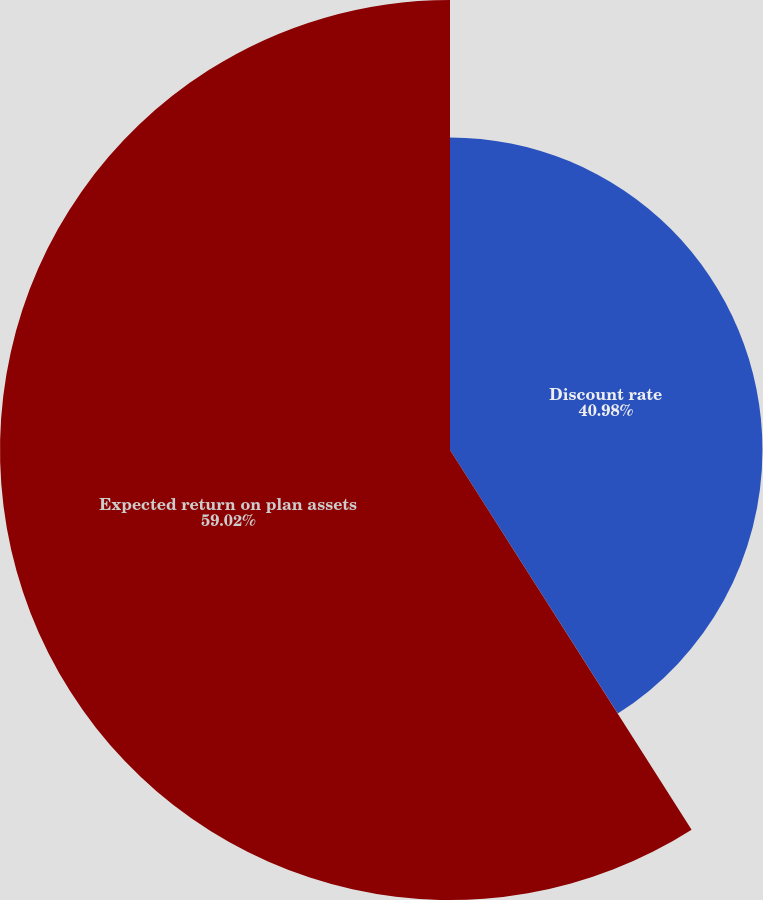Convert chart. <chart><loc_0><loc_0><loc_500><loc_500><pie_chart><fcel>Discount rate<fcel>Expected return on plan assets<nl><fcel>40.98%<fcel>59.02%<nl></chart> 